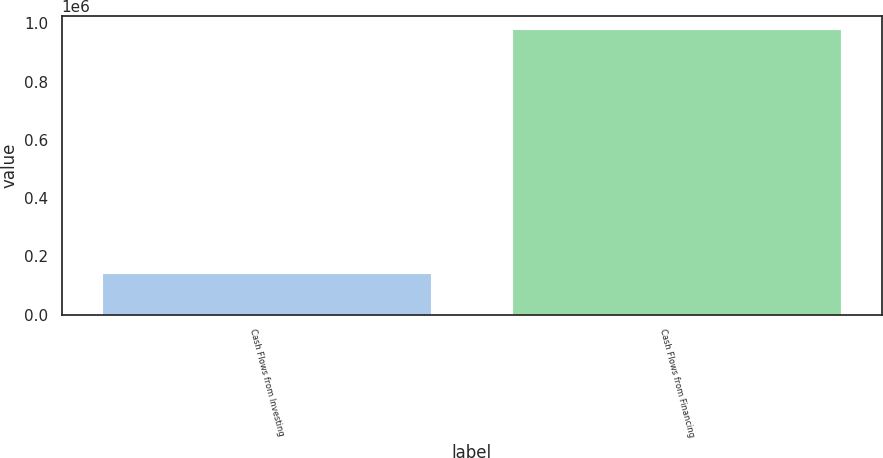Convert chart. <chart><loc_0><loc_0><loc_500><loc_500><bar_chart><fcel>Cash Flows from Investing<fcel>Cash Flows from Financing<nl><fcel>139902<fcel>977773<nl></chart> 